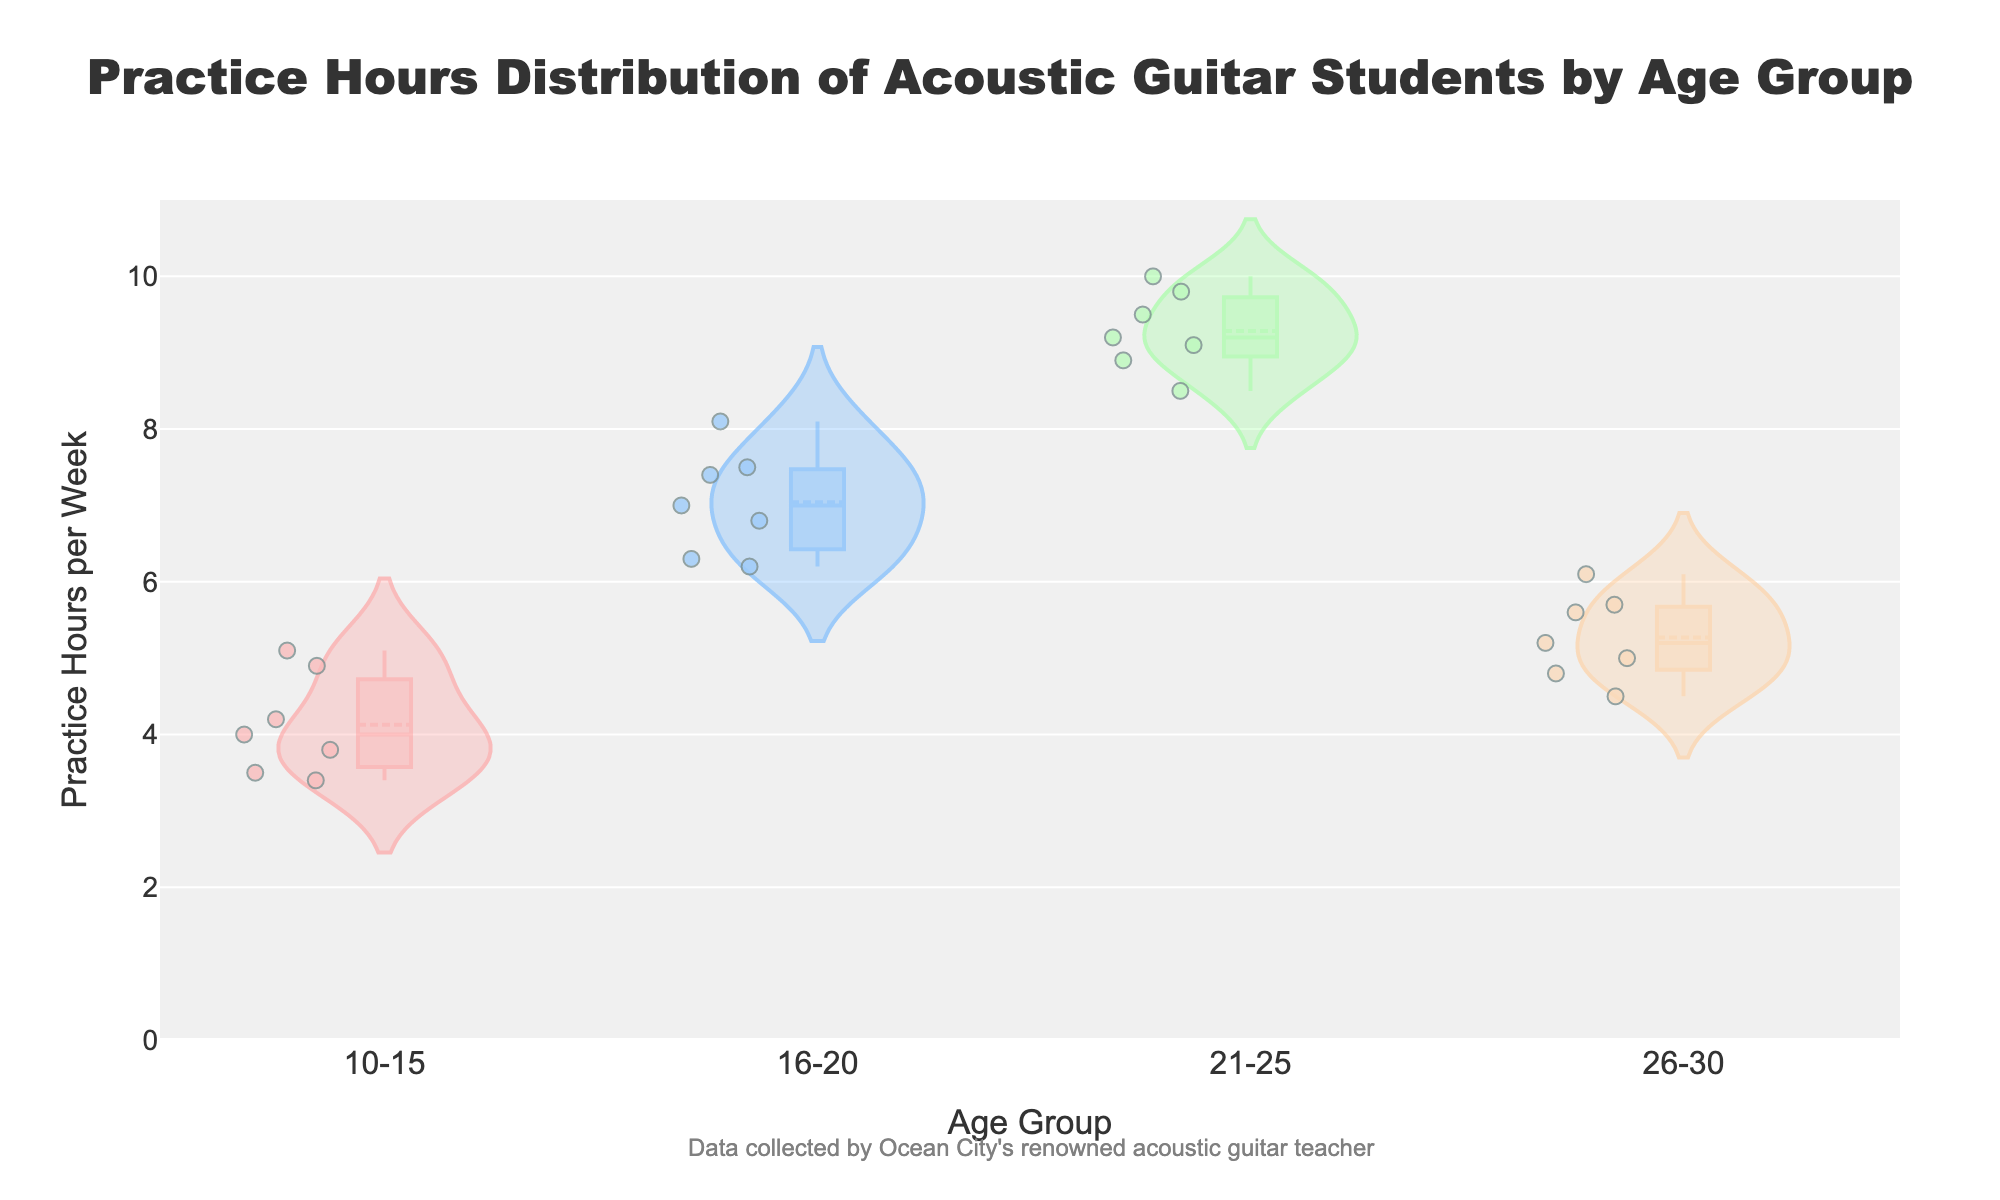What's the title of the figure? The title of the figure is prominently displayed at the top. It reads "Practice Hours Distribution of Acoustic Guitar Students by Age Group".
Answer: "Practice Hours Distribution of Acoustic Guitar Students by Age Group" What is the average practice hours per week for students aged 16-20? To calculate the average, sum the practice hours of students aged 16-20 (7.5 + 6.3 + 8.1 + 7.0 + 6.8 + 7.4 + 6.2 = 49.3) and divide by the number of students (7). Thus, the average is 49.3/7.
Answer: 7.04 Which age group has the highest median practice hours? The median practice hours can be visually estimated from the center line inside each violin plot. The age group 21-25 has the highest median value.
Answer: 21-25 Are there more outliers in the 10-15 age group or the 16-20 age group? Outliers are represented as individual points outside the main violin shape. By viewing the figure, you can see that the 16-20 age group has more scattered outlier points compared to the 10-15 age group.
Answer: 16-20 Which age group has the widest range of practice hours? The range can be assessed by the length of the violin plot. The 21-25 age group exhibits the widest range, indicating substantial variability in practice hours.
Answer: 21-25 How many students are there in the 26-30 age group? We can count the number of points within the violin plot for the 26-30 age group. There are 7 points.
Answer: 7 Is the mean line closer to the top or bottom of the interval for students aged 21-25? In the 21-25 age group, the mean line (visible as a horizontal line) is closer to the top, indicating a higher average practice hour.
Answer: Top Compare the spread of practice hours between the 10-15 and 26-30 age groups. Which has more variability? Variability is indicated by the width and total length of the violin plots. The 26-30 age group has a slightly more confined spread compared to the 10-15 age group, making the 10-15 age group more variable.
Answer: 10-15 